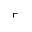<formula> <loc_0><loc_0><loc_500><loc_500>\ulcorner</formula> 